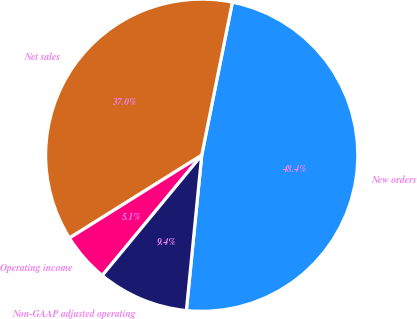Convert chart to OTSL. <chart><loc_0><loc_0><loc_500><loc_500><pie_chart><fcel>New orders<fcel>Net sales<fcel>Operating income<fcel>Non-GAAP adjusted operating<nl><fcel>48.42%<fcel>37.05%<fcel>5.1%<fcel>9.43%<nl></chart> 